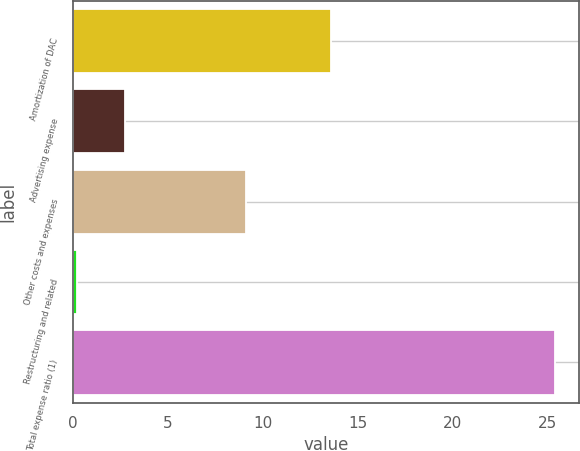Convert chart. <chart><loc_0><loc_0><loc_500><loc_500><bar_chart><fcel>Amortization of DAC<fcel>Advertising expense<fcel>Other costs and expenses<fcel>Restructuring and related<fcel>Total expense ratio (1)<nl><fcel>13.6<fcel>2.72<fcel>9.1<fcel>0.2<fcel>25.4<nl></chart> 